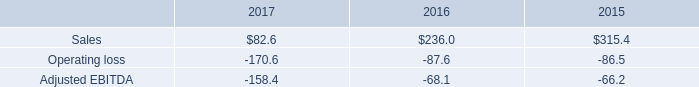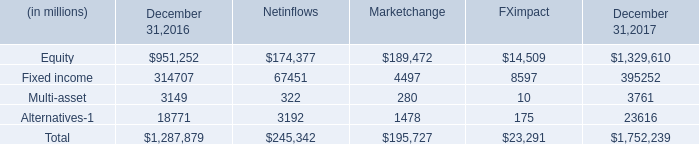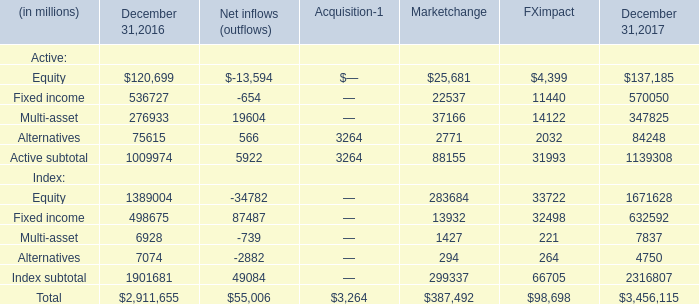If Multi-asset develops with the same increasing rate in 2017, what will it reach in 2018? (in million) 
Computations: (3761 * (1 + ((3761 - 3149) / 3149)))
Answer: 4491.94062. 